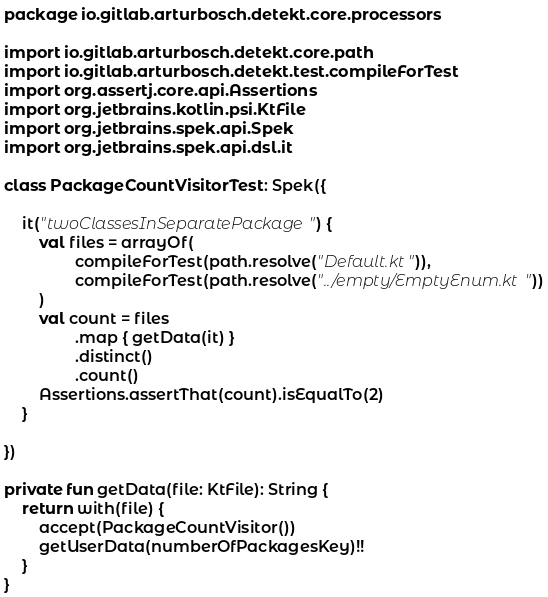Convert code to text. <code><loc_0><loc_0><loc_500><loc_500><_Kotlin_>package io.gitlab.arturbosch.detekt.core.processors

import io.gitlab.arturbosch.detekt.core.path
import io.gitlab.arturbosch.detekt.test.compileForTest
import org.assertj.core.api.Assertions
import org.jetbrains.kotlin.psi.KtFile
import org.jetbrains.spek.api.Spek
import org.jetbrains.spek.api.dsl.it

class PackageCountVisitorTest : Spek({

	it("twoClassesInSeparatePackage") {
		val files = arrayOf(
				compileForTest(path.resolve("Default.kt")),
				compileForTest(path.resolve("../empty/EmptyEnum.kt"))
		)
		val count = files
				.map { getData(it) }
				.distinct()
				.count()
		Assertions.assertThat(count).isEqualTo(2)
	}

})

private fun getData(file: KtFile): String {
	return with(file) {
		accept(PackageCountVisitor())
		getUserData(numberOfPackagesKey)!!
	}
}
</code> 